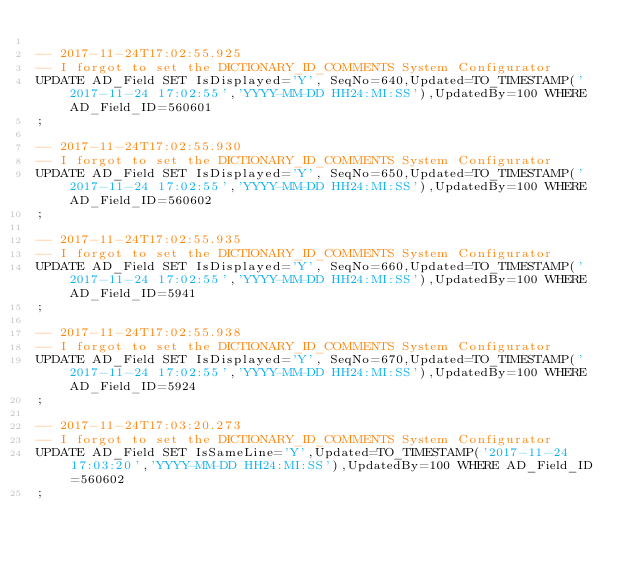Convert code to text. <code><loc_0><loc_0><loc_500><loc_500><_SQL_>
-- 2017-11-24T17:02:55.925
-- I forgot to set the DICTIONARY_ID_COMMENTS System Configurator
UPDATE AD_Field SET IsDisplayed='Y', SeqNo=640,Updated=TO_TIMESTAMP('2017-11-24 17:02:55','YYYY-MM-DD HH24:MI:SS'),UpdatedBy=100 WHERE AD_Field_ID=560601
;

-- 2017-11-24T17:02:55.930
-- I forgot to set the DICTIONARY_ID_COMMENTS System Configurator
UPDATE AD_Field SET IsDisplayed='Y', SeqNo=650,Updated=TO_TIMESTAMP('2017-11-24 17:02:55','YYYY-MM-DD HH24:MI:SS'),UpdatedBy=100 WHERE AD_Field_ID=560602
;

-- 2017-11-24T17:02:55.935
-- I forgot to set the DICTIONARY_ID_COMMENTS System Configurator
UPDATE AD_Field SET IsDisplayed='Y', SeqNo=660,Updated=TO_TIMESTAMP('2017-11-24 17:02:55','YYYY-MM-DD HH24:MI:SS'),UpdatedBy=100 WHERE AD_Field_ID=5941
;

-- 2017-11-24T17:02:55.938
-- I forgot to set the DICTIONARY_ID_COMMENTS System Configurator
UPDATE AD_Field SET IsDisplayed='Y', SeqNo=670,Updated=TO_TIMESTAMP('2017-11-24 17:02:55','YYYY-MM-DD HH24:MI:SS'),UpdatedBy=100 WHERE AD_Field_ID=5924
;

-- 2017-11-24T17:03:20.273
-- I forgot to set the DICTIONARY_ID_COMMENTS System Configurator
UPDATE AD_Field SET IsSameLine='Y',Updated=TO_TIMESTAMP('2017-11-24 17:03:20','YYYY-MM-DD HH24:MI:SS'),UpdatedBy=100 WHERE AD_Field_ID=560602
;

</code> 